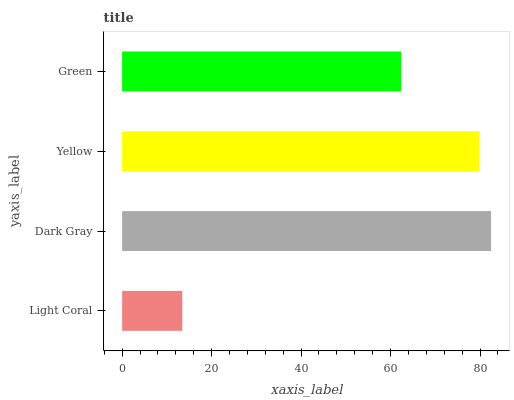Is Light Coral the minimum?
Answer yes or no. Yes. Is Dark Gray the maximum?
Answer yes or no. Yes. Is Yellow the minimum?
Answer yes or no. No. Is Yellow the maximum?
Answer yes or no. No. Is Dark Gray greater than Yellow?
Answer yes or no. Yes. Is Yellow less than Dark Gray?
Answer yes or no. Yes. Is Yellow greater than Dark Gray?
Answer yes or no. No. Is Dark Gray less than Yellow?
Answer yes or no. No. Is Yellow the high median?
Answer yes or no. Yes. Is Green the low median?
Answer yes or no. Yes. Is Green the high median?
Answer yes or no. No. Is Dark Gray the low median?
Answer yes or no. No. 